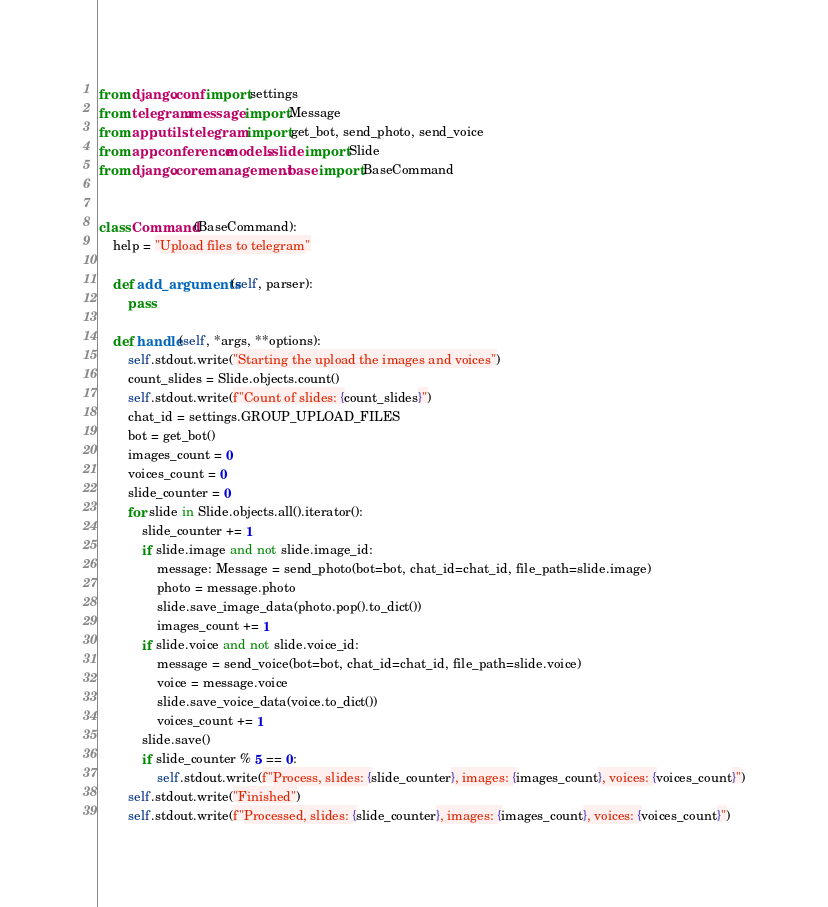Convert code to text. <code><loc_0><loc_0><loc_500><loc_500><_Python_>from django.conf import settings
from telegram.message import Message
from app.utils.telegram import get_bot, send_photo, send_voice
from app.conference.models.slide import Slide
from django.core.management.base import BaseCommand


class Command(BaseCommand):
    help = "Upload files to telegram"

    def add_arguments(self, parser):
        pass

    def handle(self, *args, **options):
        self.stdout.write("Starting the upload the images and voices")
        count_slides = Slide.objects.count()
        self.stdout.write(f"Count of slides: {count_slides}")
        chat_id = settings.GROUP_UPLOAD_FILES
        bot = get_bot()
        images_count = 0
        voices_count = 0
        slide_counter = 0
        for slide in Slide.objects.all().iterator():
            slide_counter += 1
            if slide.image and not slide.image_id:
                message: Message = send_photo(bot=bot, chat_id=chat_id, file_path=slide.image)
                photo = message.photo
                slide.save_image_data(photo.pop().to_dict())
                images_count += 1
            if slide.voice and not slide.voice_id:
                message = send_voice(bot=bot, chat_id=chat_id, file_path=slide.voice)
                voice = message.voice
                slide.save_voice_data(voice.to_dict())
                voices_count += 1
            slide.save()
            if slide_counter % 5 == 0:
                self.stdout.write(f"Process, slides: {slide_counter}, images: {images_count}, voices: {voices_count}")
        self.stdout.write("Finished")
        self.stdout.write(f"Processed, slides: {slide_counter}, images: {images_count}, voices: {voices_count}")
</code> 